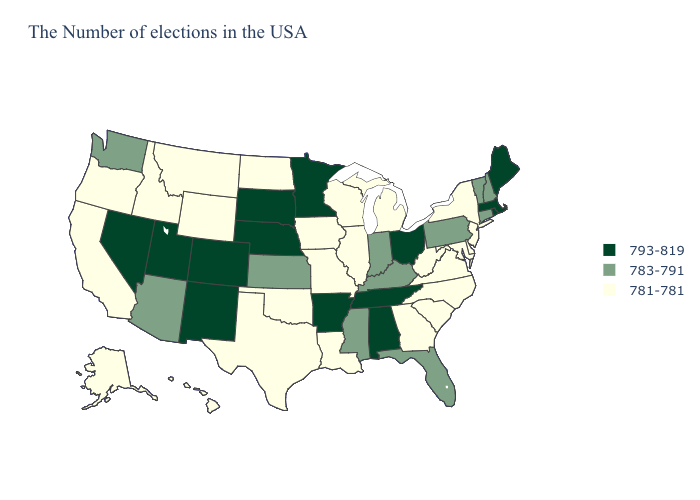Name the states that have a value in the range 783-791?
Quick response, please. New Hampshire, Vermont, Connecticut, Pennsylvania, Florida, Kentucky, Indiana, Mississippi, Kansas, Arizona, Washington. Name the states that have a value in the range 781-781?
Keep it brief. New York, New Jersey, Delaware, Maryland, Virginia, North Carolina, South Carolina, West Virginia, Georgia, Michigan, Wisconsin, Illinois, Louisiana, Missouri, Iowa, Oklahoma, Texas, North Dakota, Wyoming, Montana, Idaho, California, Oregon, Alaska, Hawaii. Does Nebraska have a higher value than Minnesota?
Write a very short answer. No. Which states hav the highest value in the MidWest?
Give a very brief answer. Ohio, Minnesota, Nebraska, South Dakota. Name the states that have a value in the range 781-781?
Answer briefly. New York, New Jersey, Delaware, Maryland, Virginia, North Carolina, South Carolina, West Virginia, Georgia, Michigan, Wisconsin, Illinois, Louisiana, Missouri, Iowa, Oklahoma, Texas, North Dakota, Wyoming, Montana, Idaho, California, Oregon, Alaska, Hawaii. Is the legend a continuous bar?
Keep it brief. No. Does California have the highest value in the West?
Give a very brief answer. No. What is the value of Ohio?
Short answer required. 793-819. Does the first symbol in the legend represent the smallest category?
Keep it brief. No. What is the value of Mississippi?
Answer briefly. 783-791. Name the states that have a value in the range 781-781?
Give a very brief answer. New York, New Jersey, Delaware, Maryland, Virginia, North Carolina, South Carolina, West Virginia, Georgia, Michigan, Wisconsin, Illinois, Louisiana, Missouri, Iowa, Oklahoma, Texas, North Dakota, Wyoming, Montana, Idaho, California, Oregon, Alaska, Hawaii. What is the value of West Virginia?
Give a very brief answer. 781-781. Among the states that border Massachusetts , which have the lowest value?
Write a very short answer. New York. Among the states that border Iowa , does Nebraska have the highest value?
Write a very short answer. Yes. Name the states that have a value in the range 793-819?
Be succinct. Maine, Massachusetts, Rhode Island, Ohio, Alabama, Tennessee, Arkansas, Minnesota, Nebraska, South Dakota, Colorado, New Mexico, Utah, Nevada. 